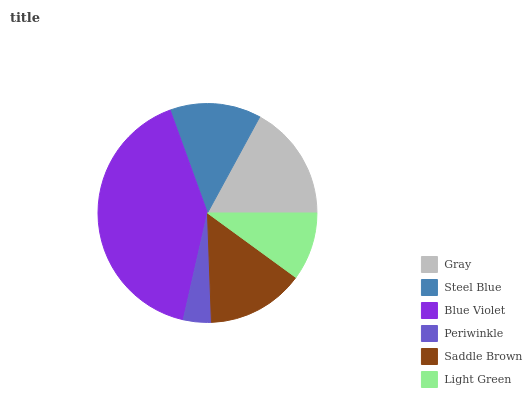Is Periwinkle the minimum?
Answer yes or no. Yes. Is Blue Violet the maximum?
Answer yes or no. Yes. Is Steel Blue the minimum?
Answer yes or no. No. Is Steel Blue the maximum?
Answer yes or no. No. Is Gray greater than Steel Blue?
Answer yes or no. Yes. Is Steel Blue less than Gray?
Answer yes or no. Yes. Is Steel Blue greater than Gray?
Answer yes or no. No. Is Gray less than Steel Blue?
Answer yes or no. No. Is Saddle Brown the high median?
Answer yes or no. Yes. Is Steel Blue the low median?
Answer yes or no. Yes. Is Gray the high median?
Answer yes or no. No. Is Gray the low median?
Answer yes or no. No. 